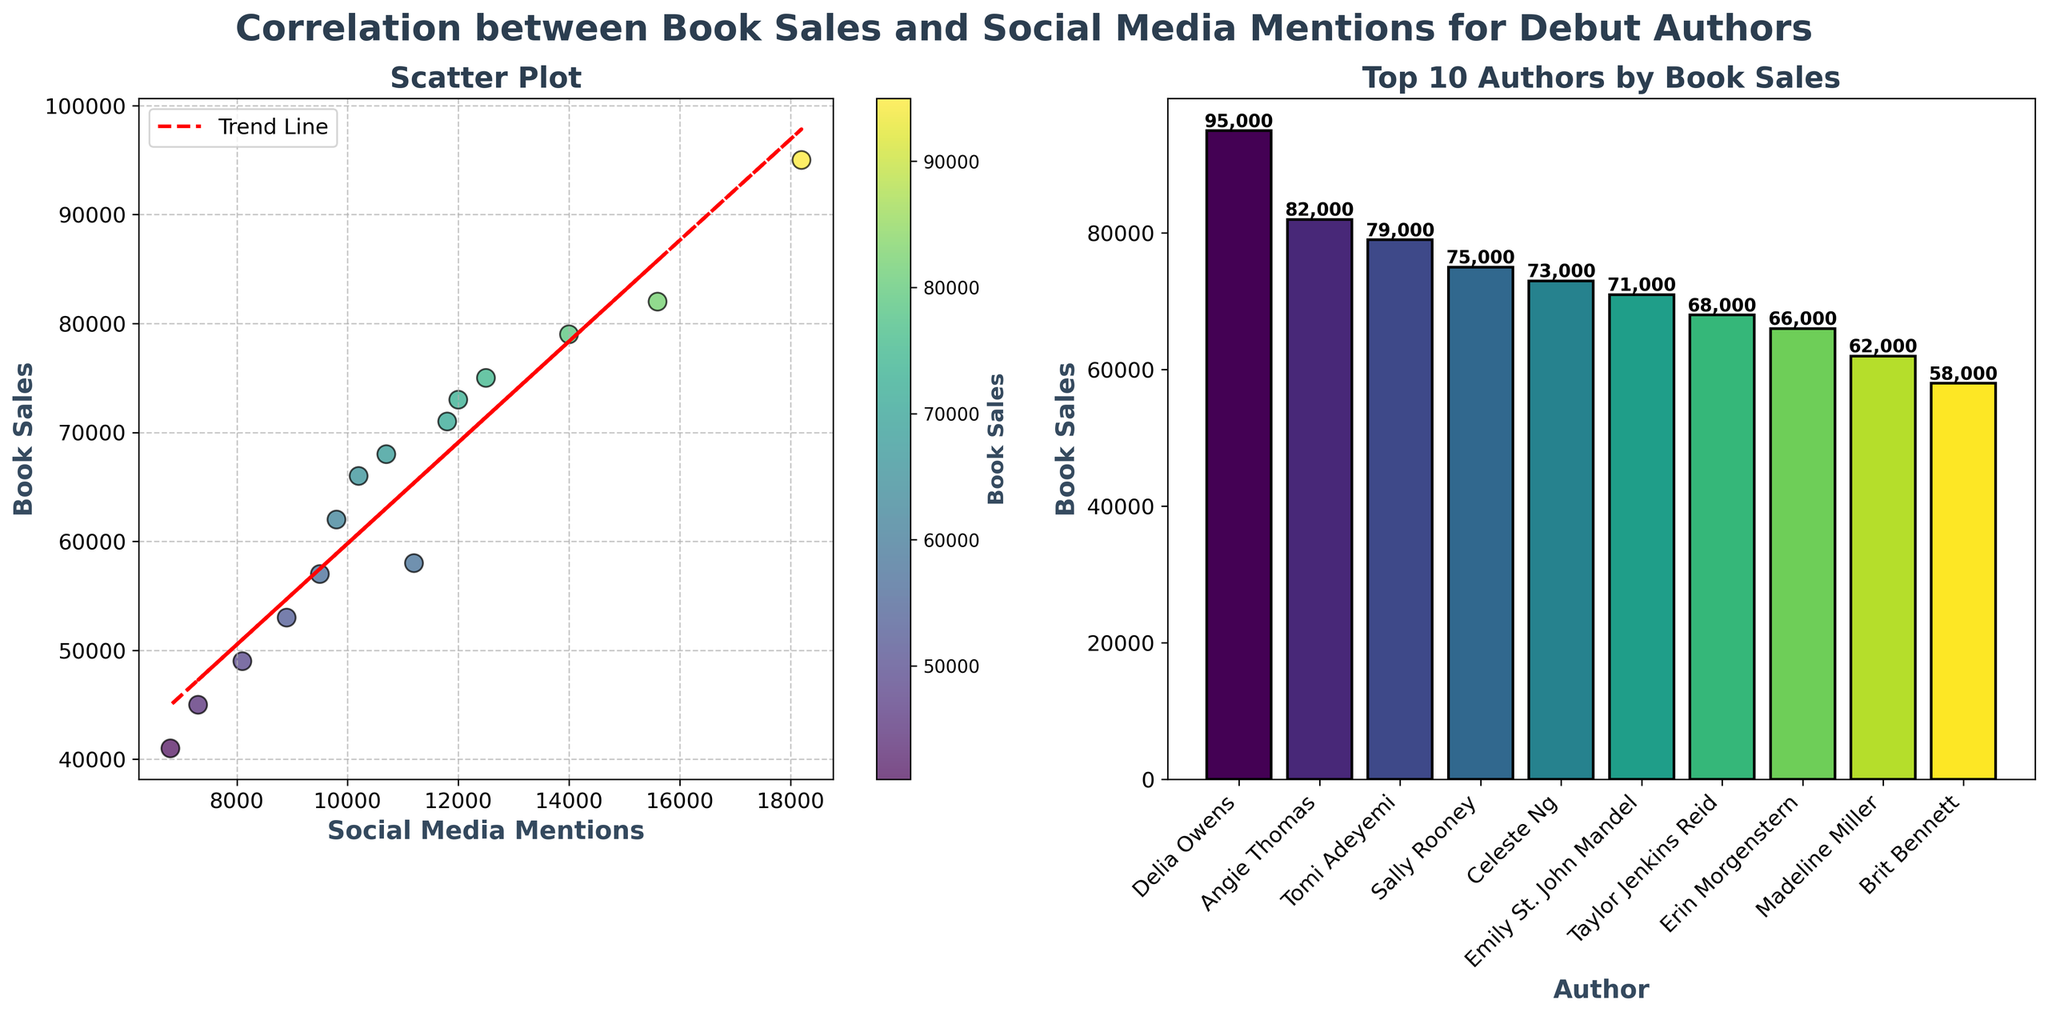How many authors are plotted in the scatter plot? Count the number of data points (dots) in the scatter plot. Each dot represents an author.
Answer: 15 Which author has the highest book sales? Refer to the bar plot on the right. The tallest bar indicates the highest book sales, and it is labeled with the author's name.
Answer: Delia Owens What's the correlation trend between book sales and social media mentions? Look at the trend line in the scatter plot. The line's slope indicates whether there's a positive or negative relationship.
Answer: Positive Which author has the most social media mentions? In the scatter plot, look for the dot farthest to the right on the x-axis, which represents social media mentions.
Answer: Delia Owens What is the book sales value for Angie Thomas? Locate the dot corresponding to Angie Thomas in the scatter plot. Check its y-axis value for book sales.
Answer: 82,000 Identify two authors with similar book sales but different social media mentions. Compare the vertical positions of dots (similar y-axis values) while ensuring their horizontal positions (x-axis values) differ.
Answer: Brit Bennett and Madeline Miller What is the general trend shown by the trend line in the scatter plot? Observe the direction and angle of the trend line. It suggests whether book sales tend to increase or decrease with more social media mentions.
Answer: Increase Which author's bar is third tallest in the bar plot? Count the bars from tallest to third tallest by descending height. Read the label of the third tallest bar.
Answer: Angie Thomas Estimate the book sales for an author with 10,200 social media mentions. Locate the point on the trend line at 10,200 social media mentions (x-axis). Check the corresponding book sales value (y-axis).
Answer: Around 66,000 Do higher social media mentions guarantee higher book sales? Review the scattering of dots in the scatter plot. If there are some low-book-sales dots with high mentions, it suggests that higher mentions do not always guarantee higher sales.
Answer: No 